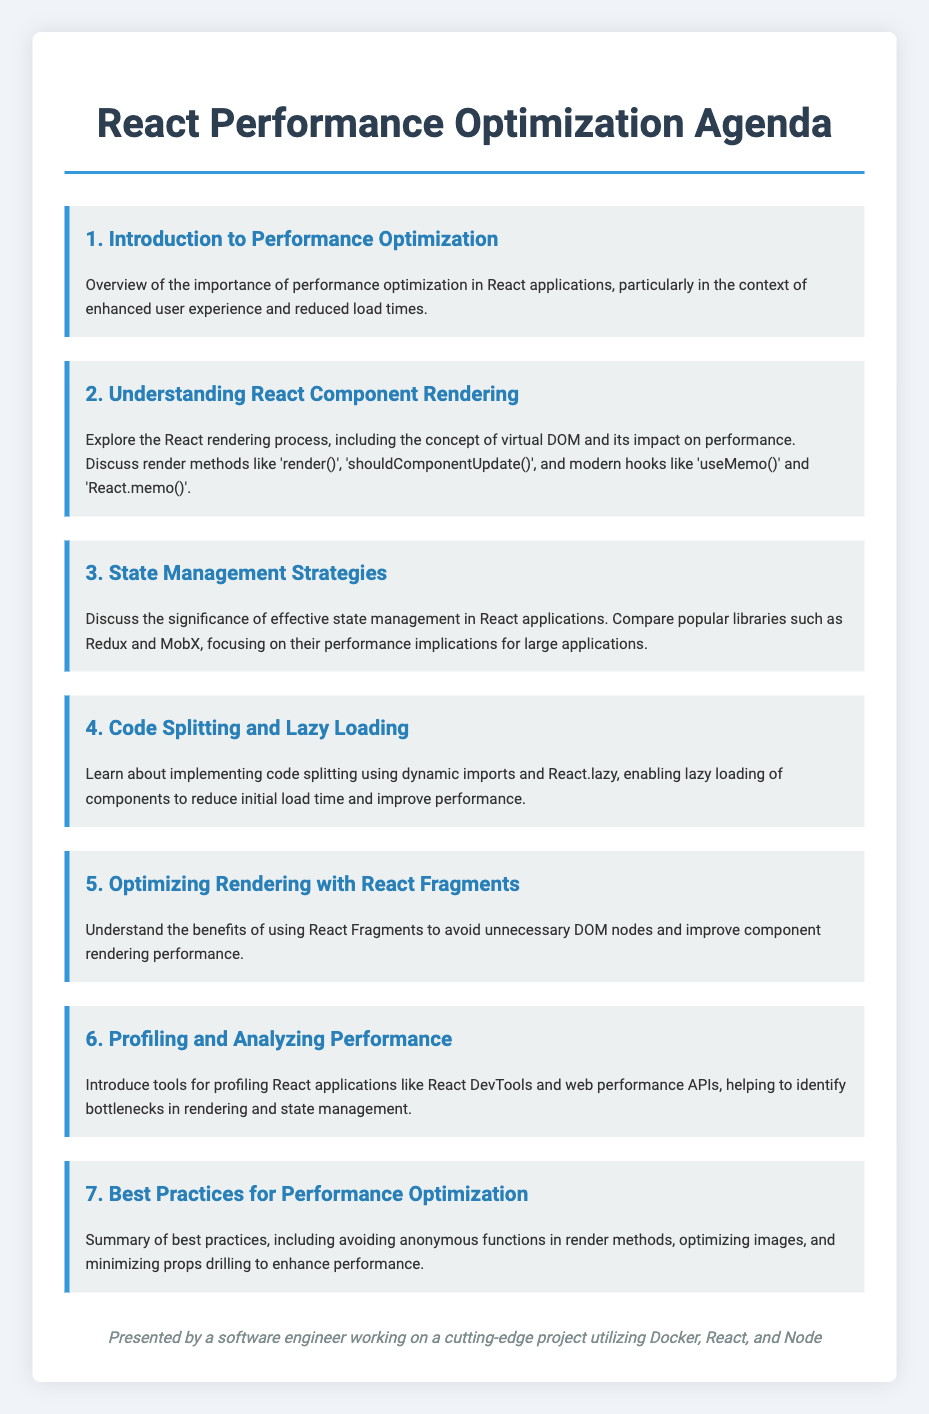What is the title of the agenda? The title of the agenda is explicitly stated at the top of the document.
Answer: React Performance Optimization Agenda How many main topics are discussed in the agenda? The number of main topics is listed in the agenda items, which are numbered from 1 to 7.
Answer: 7 What is the primary focus of the third agenda item? The third agenda item discusses a specific aspect regarding state management in React applications.
Answer: State Management Strategies Which React feature is mentioned for optimizing rendering in item five? Item five specifically discusses a feature of React that aids in improving component rendering performance.
Answer: React Fragments What is the subtitle of the sixth agenda item? The subtitle of the sixth agenda item focuses on profiling tools and their use in React.
Answer: Profiling and Analyzing Performance Who is presenting the agenda? The document specifies who is presenting the agenda at the conclusion.
Answer: A software engineer working on a cutting-edge project utilizing Docker, React, and Node What technique is highlighted in the fourth agenda item for reducing load time? The fourth agenda item emphasizes a technique that allows for components to be loaded only when needed, thereby improving load times.
Answer: Code Splitting and Lazy Loading What performance optimization topic is introduced in the first agenda item? The first agenda item provides an overview of the significance and benefits of optimizing performance.
Answer: Introduction to Performance Optimization 